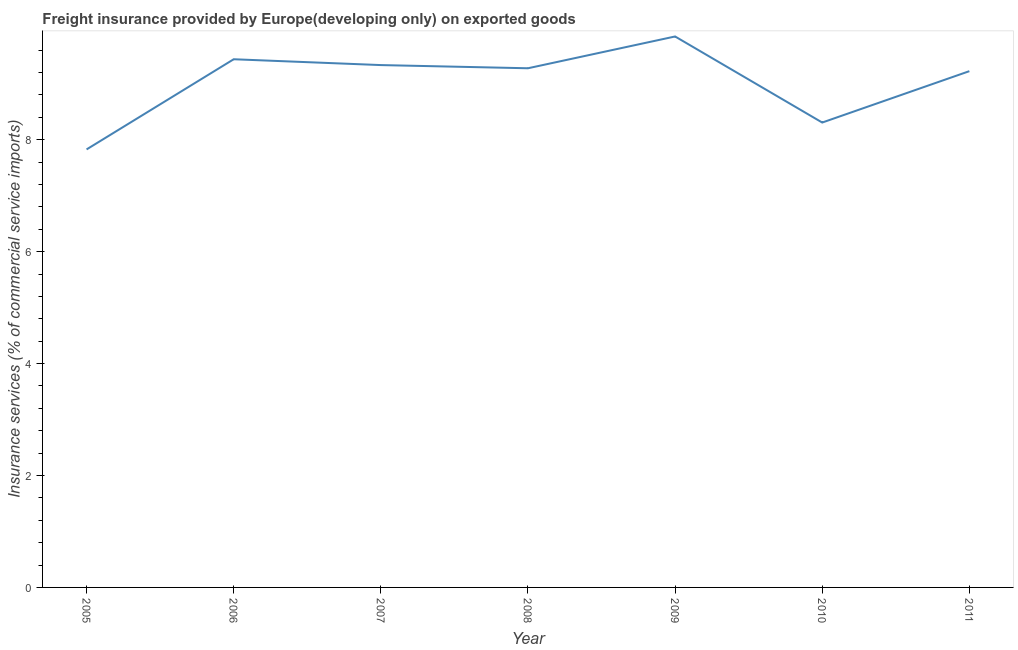What is the freight insurance in 2011?
Ensure brevity in your answer.  9.22. Across all years, what is the maximum freight insurance?
Your response must be concise. 9.84. Across all years, what is the minimum freight insurance?
Provide a succinct answer. 7.83. What is the sum of the freight insurance?
Your answer should be very brief. 63.25. What is the difference between the freight insurance in 2006 and 2011?
Ensure brevity in your answer.  0.21. What is the average freight insurance per year?
Offer a very short reply. 9.04. What is the median freight insurance?
Your answer should be compact. 9.28. In how many years, is the freight insurance greater than 6.4 %?
Offer a very short reply. 7. Do a majority of the years between 2005 and 2008 (inclusive) have freight insurance greater than 4.8 %?
Provide a succinct answer. Yes. What is the ratio of the freight insurance in 2005 to that in 2010?
Keep it short and to the point. 0.94. Is the difference between the freight insurance in 2005 and 2006 greater than the difference between any two years?
Your answer should be compact. No. What is the difference between the highest and the second highest freight insurance?
Provide a short and direct response. 0.41. Is the sum of the freight insurance in 2005 and 2009 greater than the maximum freight insurance across all years?
Provide a short and direct response. Yes. What is the difference between the highest and the lowest freight insurance?
Your response must be concise. 2.02. In how many years, is the freight insurance greater than the average freight insurance taken over all years?
Offer a very short reply. 5. Does the freight insurance monotonically increase over the years?
Provide a succinct answer. No. How many lines are there?
Give a very brief answer. 1. How many years are there in the graph?
Offer a terse response. 7. What is the difference between two consecutive major ticks on the Y-axis?
Provide a short and direct response. 2. Does the graph contain any zero values?
Keep it short and to the point. No. Does the graph contain grids?
Ensure brevity in your answer.  No. What is the title of the graph?
Your answer should be very brief. Freight insurance provided by Europe(developing only) on exported goods . What is the label or title of the X-axis?
Make the answer very short. Year. What is the label or title of the Y-axis?
Keep it short and to the point. Insurance services (% of commercial service imports). What is the Insurance services (% of commercial service imports) in 2005?
Provide a short and direct response. 7.83. What is the Insurance services (% of commercial service imports) in 2006?
Offer a very short reply. 9.44. What is the Insurance services (% of commercial service imports) in 2007?
Make the answer very short. 9.33. What is the Insurance services (% of commercial service imports) of 2008?
Give a very brief answer. 9.28. What is the Insurance services (% of commercial service imports) of 2009?
Your answer should be very brief. 9.84. What is the Insurance services (% of commercial service imports) of 2010?
Make the answer very short. 8.31. What is the Insurance services (% of commercial service imports) of 2011?
Offer a terse response. 9.22. What is the difference between the Insurance services (% of commercial service imports) in 2005 and 2006?
Your response must be concise. -1.61. What is the difference between the Insurance services (% of commercial service imports) in 2005 and 2007?
Give a very brief answer. -1.51. What is the difference between the Insurance services (% of commercial service imports) in 2005 and 2008?
Ensure brevity in your answer.  -1.45. What is the difference between the Insurance services (% of commercial service imports) in 2005 and 2009?
Give a very brief answer. -2.02. What is the difference between the Insurance services (% of commercial service imports) in 2005 and 2010?
Provide a short and direct response. -0.48. What is the difference between the Insurance services (% of commercial service imports) in 2005 and 2011?
Offer a very short reply. -1.4. What is the difference between the Insurance services (% of commercial service imports) in 2006 and 2007?
Ensure brevity in your answer.  0.1. What is the difference between the Insurance services (% of commercial service imports) in 2006 and 2008?
Give a very brief answer. 0.16. What is the difference between the Insurance services (% of commercial service imports) in 2006 and 2009?
Offer a terse response. -0.41. What is the difference between the Insurance services (% of commercial service imports) in 2006 and 2010?
Provide a succinct answer. 1.13. What is the difference between the Insurance services (% of commercial service imports) in 2006 and 2011?
Offer a very short reply. 0.21. What is the difference between the Insurance services (% of commercial service imports) in 2007 and 2008?
Offer a very short reply. 0.06. What is the difference between the Insurance services (% of commercial service imports) in 2007 and 2009?
Offer a terse response. -0.51. What is the difference between the Insurance services (% of commercial service imports) in 2007 and 2010?
Your response must be concise. 1.03. What is the difference between the Insurance services (% of commercial service imports) in 2007 and 2011?
Keep it short and to the point. 0.11. What is the difference between the Insurance services (% of commercial service imports) in 2008 and 2009?
Make the answer very short. -0.57. What is the difference between the Insurance services (% of commercial service imports) in 2008 and 2010?
Offer a very short reply. 0.97. What is the difference between the Insurance services (% of commercial service imports) in 2008 and 2011?
Your response must be concise. 0.05. What is the difference between the Insurance services (% of commercial service imports) in 2009 and 2010?
Your answer should be very brief. 1.54. What is the difference between the Insurance services (% of commercial service imports) in 2009 and 2011?
Provide a succinct answer. 0.62. What is the difference between the Insurance services (% of commercial service imports) in 2010 and 2011?
Offer a terse response. -0.92. What is the ratio of the Insurance services (% of commercial service imports) in 2005 to that in 2006?
Provide a succinct answer. 0.83. What is the ratio of the Insurance services (% of commercial service imports) in 2005 to that in 2007?
Your response must be concise. 0.84. What is the ratio of the Insurance services (% of commercial service imports) in 2005 to that in 2008?
Make the answer very short. 0.84. What is the ratio of the Insurance services (% of commercial service imports) in 2005 to that in 2009?
Offer a very short reply. 0.8. What is the ratio of the Insurance services (% of commercial service imports) in 2005 to that in 2010?
Provide a succinct answer. 0.94. What is the ratio of the Insurance services (% of commercial service imports) in 2005 to that in 2011?
Your answer should be very brief. 0.85. What is the ratio of the Insurance services (% of commercial service imports) in 2006 to that in 2010?
Offer a very short reply. 1.14. What is the ratio of the Insurance services (% of commercial service imports) in 2007 to that in 2008?
Provide a succinct answer. 1.01. What is the ratio of the Insurance services (% of commercial service imports) in 2007 to that in 2009?
Your response must be concise. 0.95. What is the ratio of the Insurance services (% of commercial service imports) in 2007 to that in 2010?
Your response must be concise. 1.12. What is the ratio of the Insurance services (% of commercial service imports) in 2008 to that in 2009?
Your response must be concise. 0.94. What is the ratio of the Insurance services (% of commercial service imports) in 2008 to that in 2010?
Offer a very short reply. 1.12. What is the ratio of the Insurance services (% of commercial service imports) in 2008 to that in 2011?
Provide a short and direct response. 1.01. What is the ratio of the Insurance services (% of commercial service imports) in 2009 to that in 2010?
Your answer should be very brief. 1.19. What is the ratio of the Insurance services (% of commercial service imports) in 2009 to that in 2011?
Your answer should be very brief. 1.07. What is the ratio of the Insurance services (% of commercial service imports) in 2010 to that in 2011?
Provide a succinct answer. 0.9. 